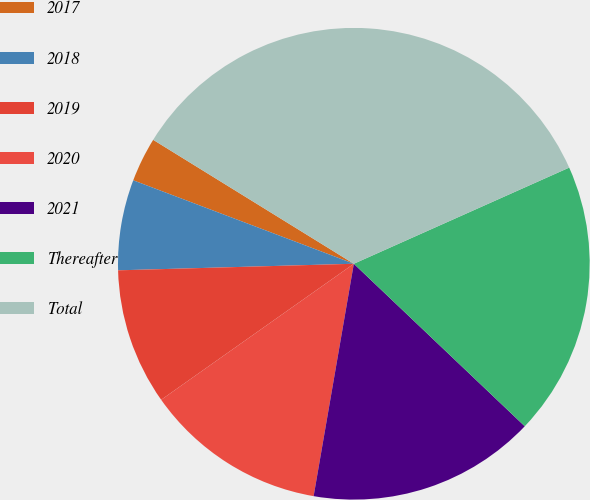Convert chart. <chart><loc_0><loc_0><loc_500><loc_500><pie_chart><fcel>2017<fcel>2018<fcel>2019<fcel>2020<fcel>2021<fcel>Thereafter<fcel>Total<nl><fcel>3.05%<fcel>6.2%<fcel>9.34%<fcel>12.49%<fcel>15.63%<fcel>18.78%<fcel>34.51%<nl></chart> 